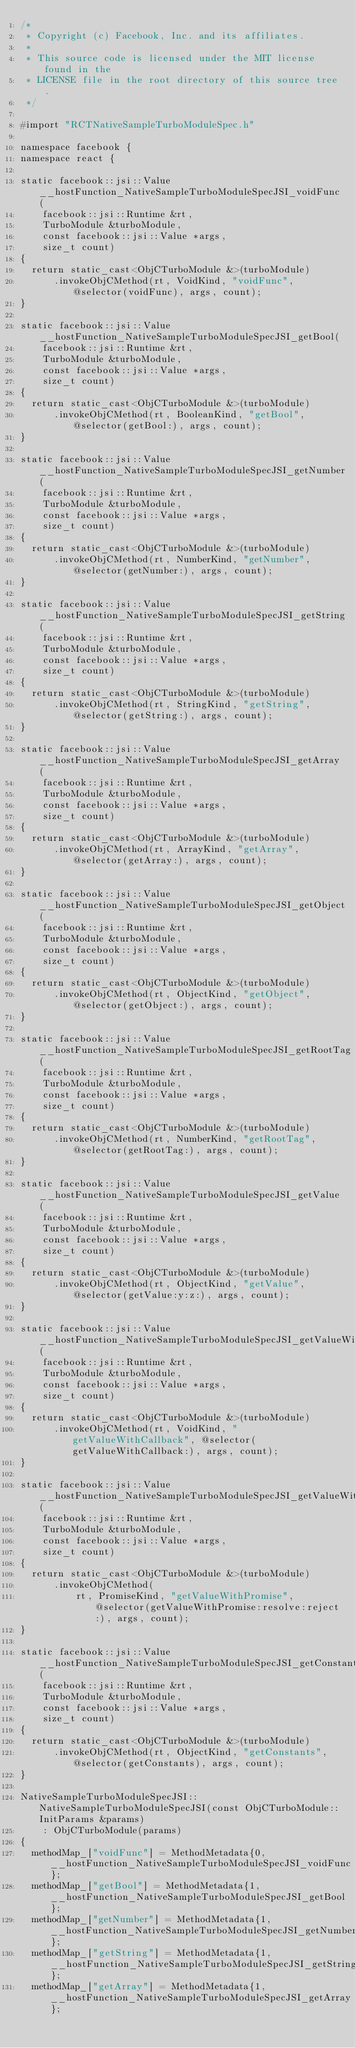Convert code to text. <code><loc_0><loc_0><loc_500><loc_500><_ObjectiveC_>/*
 * Copyright (c) Facebook, Inc. and its affiliates.
 *
 * This source code is licensed under the MIT license found in the
 * LICENSE file in the root directory of this source tree.
 */

#import "RCTNativeSampleTurboModuleSpec.h"

namespace facebook {
namespace react {

static facebook::jsi::Value __hostFunction_NativeSampleTurboModuleSpecJSI_voidFunc(
    facebook::jsi::Runtime &rt,
    TurboModule &turboModule,
    const facebook::jsi::Value *args,
    size_t count)
{
  return static_cast<ObjCTurboModule &>(turboModule)
      .invokeObjCMethod(rt, VoidKind, "voidFunc", @selector(voidFunc), args, count);
}

static facebook::jsi::Value __hostFunction_NativeSampleTurboModuleSpecJSI_getBool(
    facebook::jsi::Runtime &rt,
    TurboModule &turboModule,
    const facebook::jsi::Value *args,
    size_t count)
{
  return static_cast<ObjCTurboModule &>(turboModule)
      .invokeObjCMethod(rt, BooleanKind, "getBool", @selector(getBool:), args, count);
}

static facebook::jsi::Value __hostFunction_NativeSampleTurboModuleSpecJSI_getNumber(
    facebook::jsi::Runtime &rt,
    TurboModule &turboModule,
    const facebook::jsi::Value *args,
    size_t count)
{
  return static_cast<ObjCTurboModule &>(turboModule)
      .invokeObjCMethod(rt, NumberKind, "getNumber", @selector(getNumber:), args, count);
}

static facebook::jsi::Value __hostFunction_NativeSampleTurboModuleSpecJSI_getString(
    facebook::jsi::Runtime &rt,
    TurboModule &turboModule,
    const facebook::jsi::Value *args,
    size_t count)
{
  return static_cast<ObjCTurboModule &>(turboModule)
      .invokeObjCMethod(rt, StringKind, "getString", @selector(getString:), args, count);
}

static facebook::jsi::Value __hostFunction_NativeSampleTurboModuleSpecJSI_getArray(
    facebook::jsi::Runtime &rt,
    TurboModule &turboModule,
    const facebook::jsi::Value *args,
    size_t count)
{
  return static_cast<ObjCTurboModule &>(turboModule)
      .invokeObjCMethod(rt, ArrayKind, "getArray", @selector(getArray:), args, count);
}

static facebook::jsi::Value __hostFunction_NativeSampleTurboModuleSpecJSI_getObject(
    facebook::jsi::Runtime &rt,
    TurboModule &turboModule,
    const facebook::jsi::Value *args,
    size_t count)
{
  return static_cast<ObjCTurboModule &>(turboModule)
      .invokeObjCMethod(rt, ObjectKind, "getObject", @selector(getObject:), args, count);
}

static facebook::jsi::Value __hostFunction_NativeSampleTurboModuleSpecJSI_getRootTag(
    facebook::jsi::Runtime &rt,
    TurboModule &turboModule,
    const facebook::jsi::Value *args,
    size_t count)
{
  return static_cast<ObjCTurboModule &>(turboModule)
      .invokeObjCMethod(rt, NumberKind, "getRootTag", @selector(getRootTag:), args, count);
}

static facebook::jsi::Value __hostFunction_NativeSampleTurboModuleSpecJSI_getValue(
    facebook::jsi::Runtime &rt,
    TurboModule &turboModule,
    const facebook::jsi::Value *args,
    size_t count)
{
  return static_cast<ObjCTurboModule &>(turboModule)
      .invokeObjCMethod(rt, ObjectKind, "getValue", @selector(getValue:y:z:), args, count);
}

static facebook::jsi::Value __hostFunction_NativeSampleTurboModuleSpecJSI_getValueWithCallback(
    facebook::jsi::Runtime &rt,
    TurboModule &turboModule,
    const facebook::jsi::Value *args,
    size_t count)
{
  return static_cast<ObjCTurboModule &>(turboModule)
      .invokeObjCMethod(rt, VoidKind, "getValueWithCallback", @selector(getValueWithCallback:), args, count);
}

static facebook::jsi::Value __hostFunction_NativeSampleTurboModuleSpecJSI_getValueWithPromise(
    facebook::jsi::Runtime &rt,
    TurboModule &turboModule,
    const facebook::jsi::Value *args,
    size_t count)
{
  return static_cast<ObjCTurboModule &>(turboModule)
      .invokeObjCMethod(
          rt, PromiseKind, "getValueWithPromise", @selector(getValueWithPromise:resolve:reject:), args, count);
}

static facebook::jsi::Value __hostFunction_NativeSampleTurboModuleSpecJSI_getConstants(
    facebook::jsi::Runtime &rt,
    TurboModule &turboModule,
    const facebook::jsi::Value *args,
    size_t count)
{
  return static_cast<ObjCTurboModule &>(turboModule)
      .invokeObjCMethod(rt, ObjectKind, "getConstants", @selector(getConstants), args, count);
}

NativeSampleTurboModuleSpecJSI::NativeSampleTurboModuleSpecJSI(const ObjCTurboModule::InitParams &params)
    : ObjCTurboModule(params)
{
  methodMap_["voidFunc"] = MethodMetadata{0, __hostFunction_NativeSampleTurboModuleSpecJSI_voidFunc};
  methodMap_["getBool"] = MethodMetadata{1, __hostFunction_NativeSampleTurboModuleSpecJSI_getBool};
  methodMap_["getNumber"] = MethodMetadata{1, __hostFunction_NativeSampleTurboModuleSpecJSI_getNumber};
  methodMap_["getString"] = MethodMetadata{1, __hostFunction_NativeSampleTurboModuleSpecJSI_getString};
  methodMap_["getArray"] = MethodMetadata{1, __hostFunction_NativeSampleTurboModuleSpecJSI_getArray};</code> 